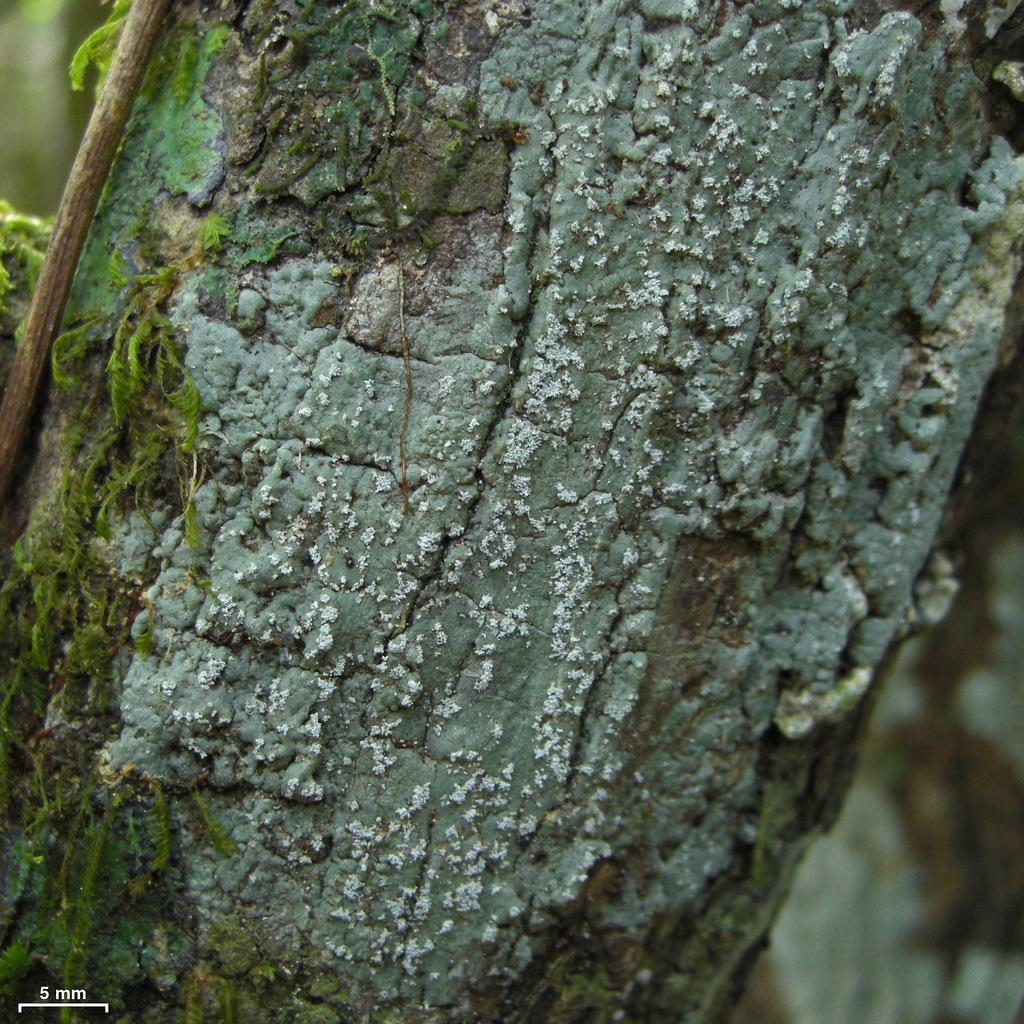What is the main subject of the image? The main subject of the image is a tree trunk. Are there any additional features on the tree trunk? Yes, there are small plants on the tree trunk. How would you describe the background of the image? The background of the image is blurred. Is there any text or logo visible in the image? Yes, there is a watermark in the left bottom corner of the image. Can you see a rabbit playing music with its partner in the image? No, there is no rabbit or any musical activity depicted in the image. The image features a tree trunk with small plants and a blurred background. 